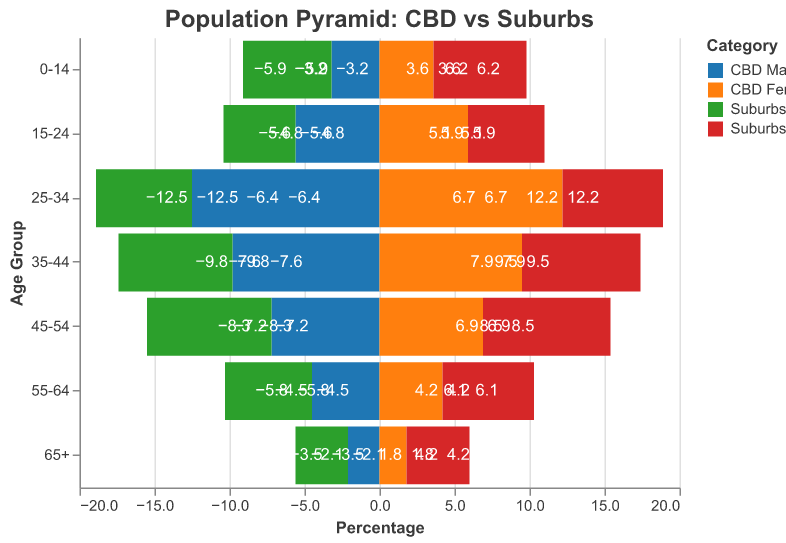What age group has the highest percentage in the central business district (CBD)? To determine which age group has the highest percentage in the CBD, look for the most extended bars in both the CBD Male and CBD Female categories. The 25-34 age group has the longest bars in both categories, indicating it has the highest percentage.
Answer: 25-34 Which gender has a higher percentage in the 15-24 age group in the suburbs? Compare the lengths of the bars for Suburbs Male and Suburbs Female in the 15-24 age group. The Suburbs Female bar is slightly longer than the Suburbs Male bar.
Answer: Female How do the percentages of the 65+ age group in the suburbs compare to those in the CBD? Look at the lengths of the bars for the 65+ age group in both the CBD Male, CBD Female, Suburbs Male, and Suburbs Female categories. The bars in the suburbs categories (Suburbs Male and Suburbs Female) are longer, indicating higher percentages compared to those in the CBD categories.
Answer: Higher in suburbs What is the combined percentage of males and females aged 45-54 in the CBD? Add the percentages of CBD Male and CBD Female for the 45-54 age group. The values are 7.2 for CBD Male and 6.9 for CBD Female. Summing these gives 7.2 + 6.9 = 14.1.
Answer: 14.1 For which age groups are there more males than females in the CBD? For each age group, compare the lengths of the bars for CBD Male and CBD Female categories to see where CBD Male is greater. The age groups where males have a greater percentage are 45-54, 35-44, and 25-34.
Answer: 45-54, 35-44, 25-34 Which population segment has the smallest percentage in the CBD? Identify the group with the shortest bars in both CBD Male and CBD Female categories. The 65+ age group has the shortest bars in both categories.
Answer: 65+ What is the total percentage of children (0-14 age group) in the suburbs? Look at the bars for Suburbs Male and Suburbs Female in the 0-14 age group, and add their values together. The values are 5.9 for Suburbs Male and 6.2 for Suburbs Female, giving 5.9 + 6.2 = 12.1.
Answer: 12.1 Which area, CBD or suburbs, has a higher percentage of people in the 25-34 age group? Compare the sum of CBD Male and CBD Female percentages to the sum of Suburbs Male and Suburbs Female percentages for the 25-34 age group. CBD has 12.5 + 12.2 = 24.7, while the suburbs have 6.4 + 6.7 = 13.1. Therefore, CBD has a higher percentage.
Answer: CBD Does the central business district or the suburbs have a higher percentage of children (0-14 age group)? Compare the sum of the percentages for the CBD Male and CBD Female categories to the sum of the percentages for the Suburbs Male and Suburbs Female categories in the 0-14 age group. CBD has 3.2 + 3.6 = 6.8, while the suburbs have 5.9 + 6.2 = 12.1. The suburbs have a higher percentage.
Answer: Suburbs 